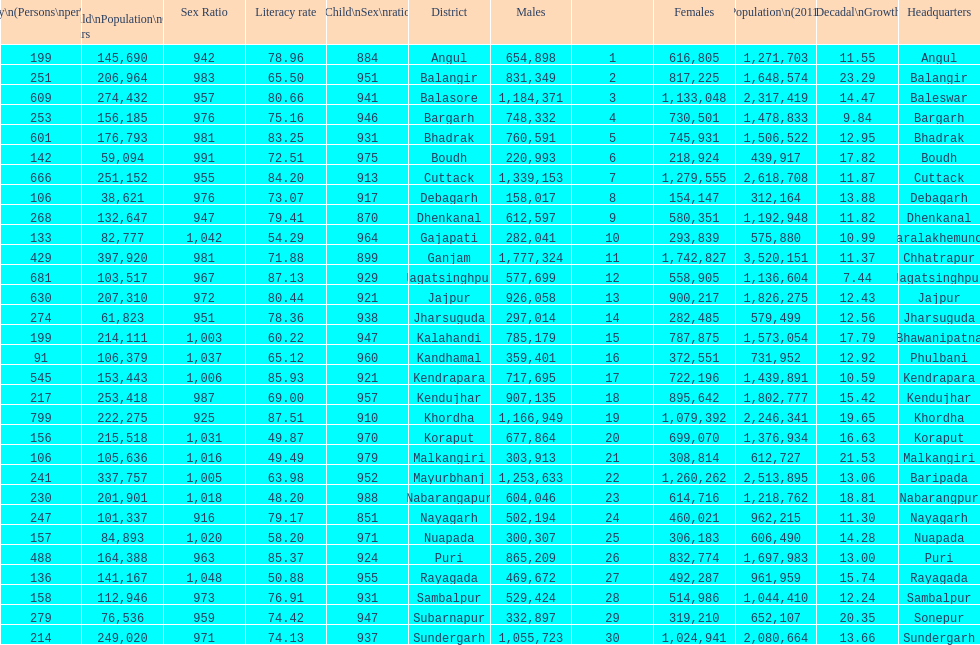What is the number of districts with percentage decadal growth above 15% 10. 